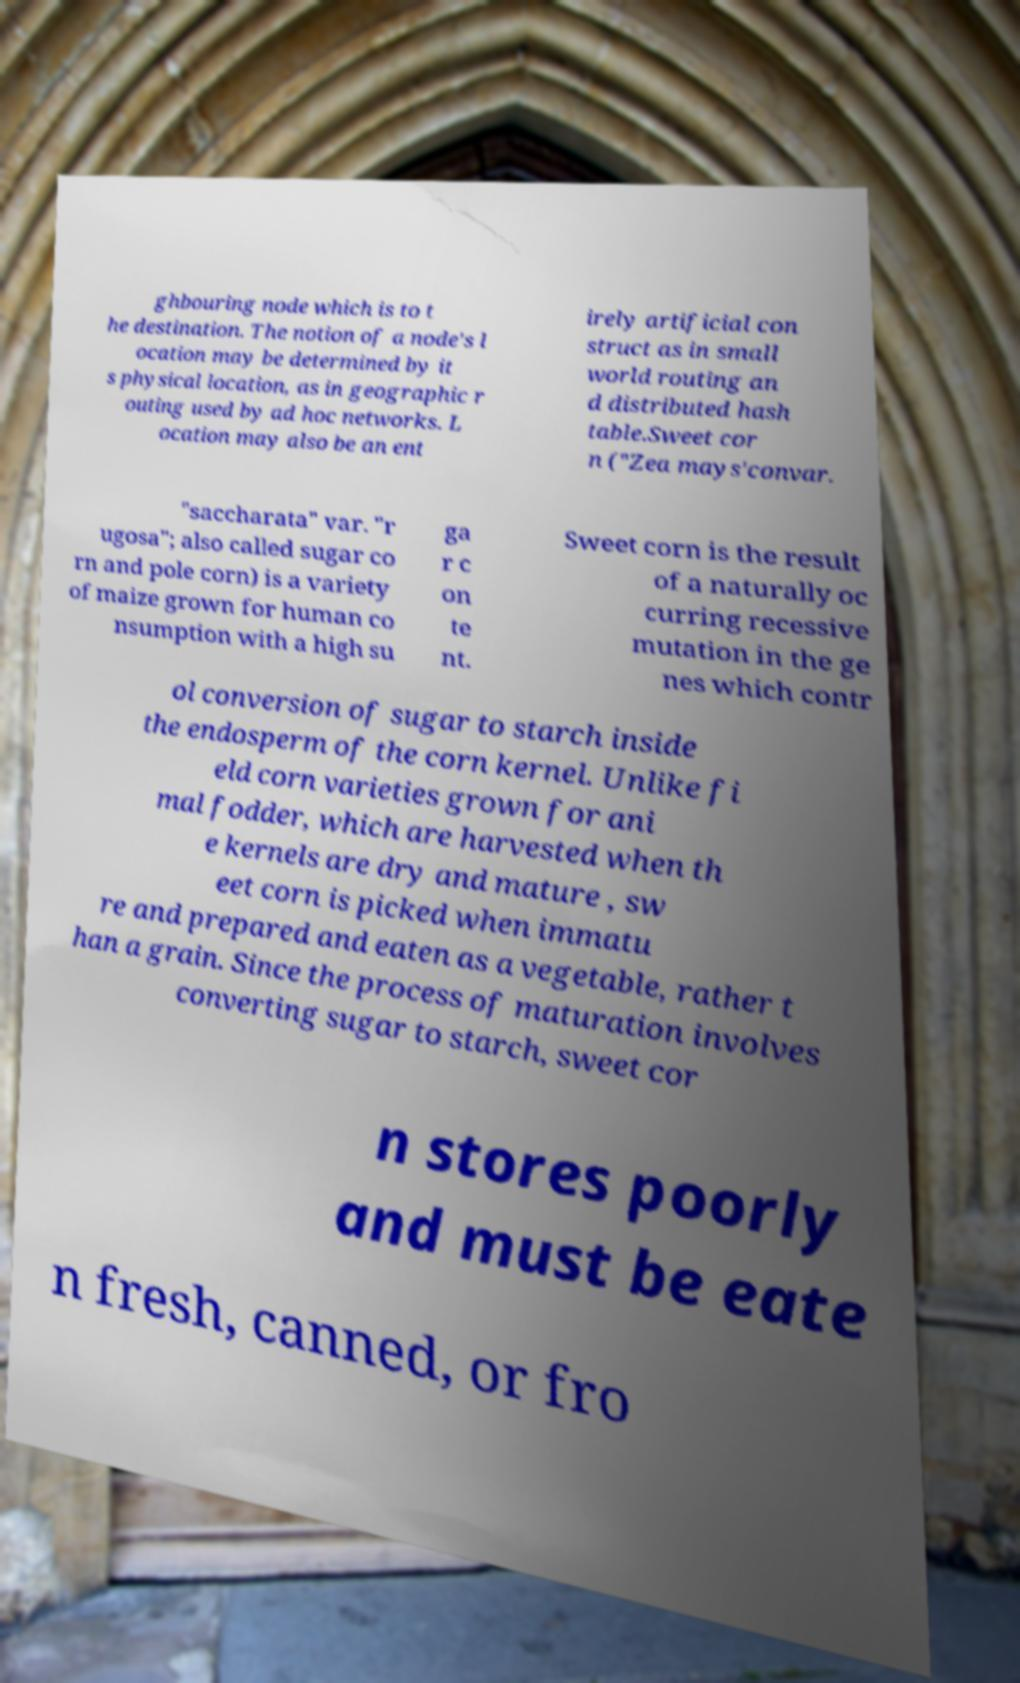Can you read and provide the text displayed in the image?This photo seems to have some interesting text. Can you extract and type it out for me? ghbouring node which is to t he destination. The notion of a node's l ocation may be determined by it s physical location, as in geographic r outing used by ad hoc networks. L ocation may also be an ent irely artificial con struct as in small world routing an d distributed hash table.Sweet cor n ("Zea mays'convar. "saccharata" var. "r ugosa"; also called sugar co rn and pole corn) is a variety of maize grown for human co nsumption with a high su ga r c on te nt. Sweet corn is the result of a naturally oc curring recessive mutation in the ge nes which contr ol conversion of sugar to starch inside the endosperm of the corn kernel. Unlike fi eld corn varieties grown for ani mal fodder, which are harvested when th e kernels are dry and mature , sw eet corn is picked when immatu re and prepared and eaten as a vegetable, rather t han a grain. Since the process of maturation involves converting sugar to starch, sweet cor n stores poorly and must be eate n fresh, canned, or fro 